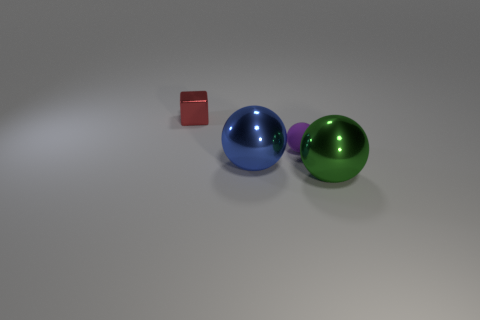What number of big blue spheres are behind the tiny red shiny object? 0 